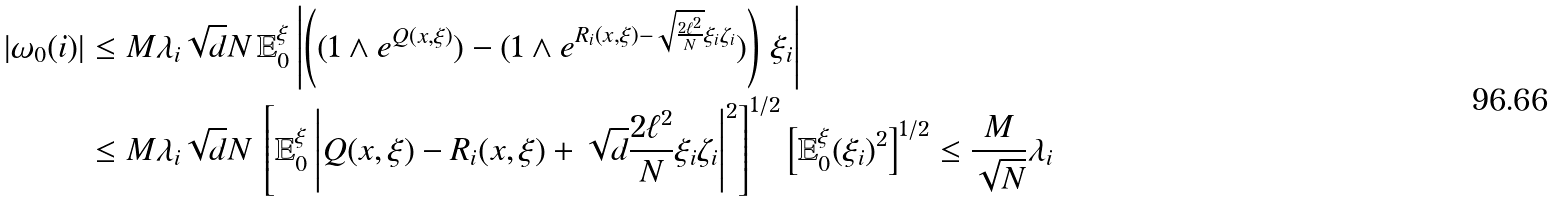<formula> <loc_0><loc_0><loc_500><loc_500>| \omega _ { 0 } ( i ) | & \leq M \lambda _ { i } \sqrt { d } { N } \, \mathbb { E } _ { 0 } ^ { \xi } \left | \left ( ( 1 \wedge e ^ { Q ( x , \xi ) } ) - ( 1 \wedge e ^ { R _ { i } ( x , \xi ) - \sqrt { \frac { 2 \ell ^ { 2 } } { N } } \xi _ { i } \zeta _ { i } } ) \right ) \, \xi _ { i } \right | \\ & \leq M \lambda _ { i } \sqrt { d } { N } \, \left [ \mathbb { E } _ { 0 } ^ { \xi } \left | Q ( x , \xi ) - R _ { i } ( x , \xi ) + \sqrt { d } { \frac { 2 \ell ^ { 2 } } { N } } \xi _ { i } \zeta _ { i } \right | ^ { 2 } \right ] ^ { 1 / 2 } \left [ \mathbb { E } ^ { \xi } _ { 0 } ( \xi _ { i } ) ^ { 2 } \right ] ^ { 1 / 2 } \leq \frac { M } { \sqrt { N } } \lambda _ { i }</formula> 